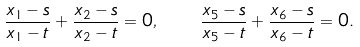Convert formula to latex. <formula><loc_0><loc_0><loc_500><loc_500>\frac { x _ { 1 } - s } { x _ { 1 } - t } + \frac { x _ { 2 } - s } { x _ { 2 } - t } = 0 , \quad \frac { x _ { 5 } - s } { x _ { 5 } - t } + \frac { x _ { 6 } - s } { x _ { 6 } - t } = 0 .</formula> 